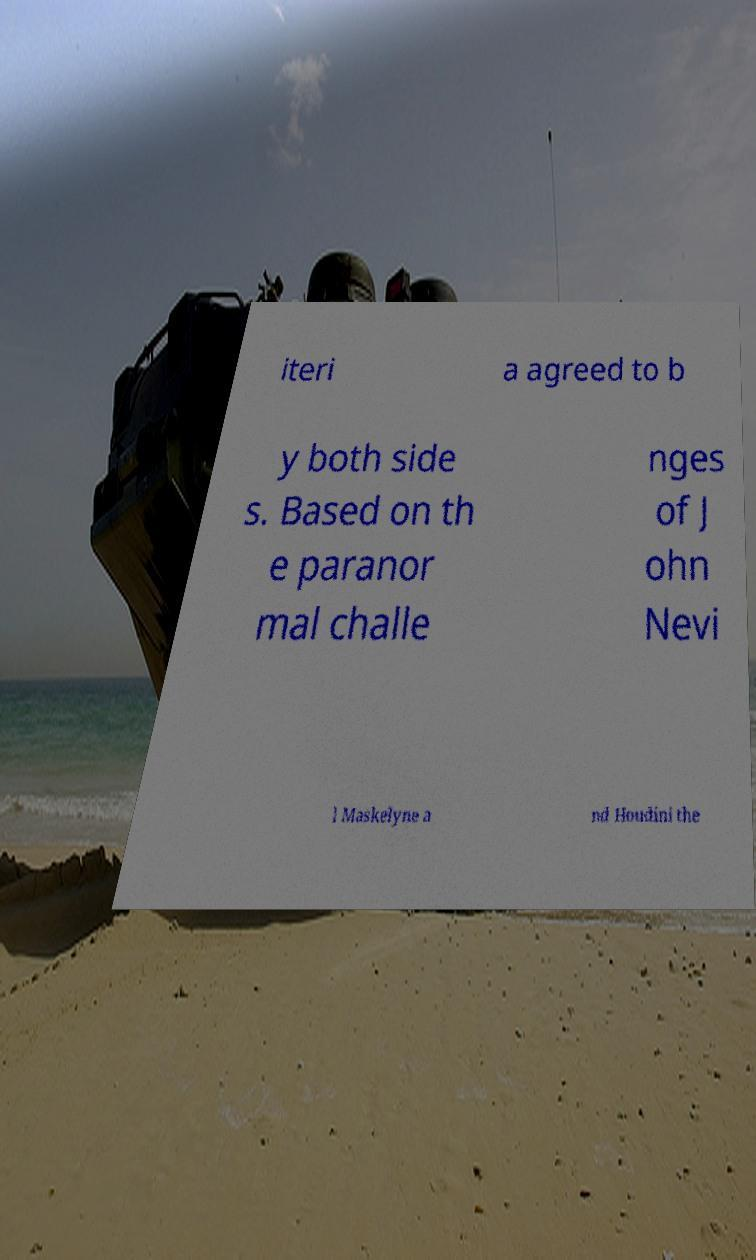There's text embedded in this image that I need extracted. Can you transcribe it verbatim? iteri a agreed to b y both side s. Based on th e paranor mal challe nges of J ohn Nevi l Maskelyne a nd Houdini the 